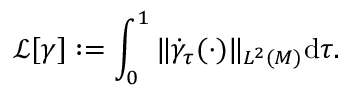Convert formula to latex. <formula><loc_0><loc_0><loc_500><loc_500>\ m a t h s c r { L } [ \gamma ] \colon = \int _ { 0 } ^ { 1 } \| \dot { \gamma } _ { \tau } ( \cdot ) \| _ { L ^ { 2 } ( M ) } d \tau .</formula> 